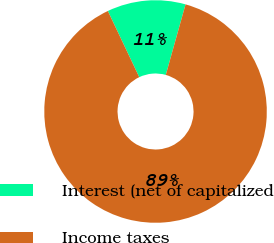Convert chart to OTSL. <chart><loc_0><loc_0><loc_500><loc_500><pie_chart><fcel>Interest (net of capitalized<fcel>Income taxes<nl><fcel>11.4%<fcel>88.6%<nl></chart> 